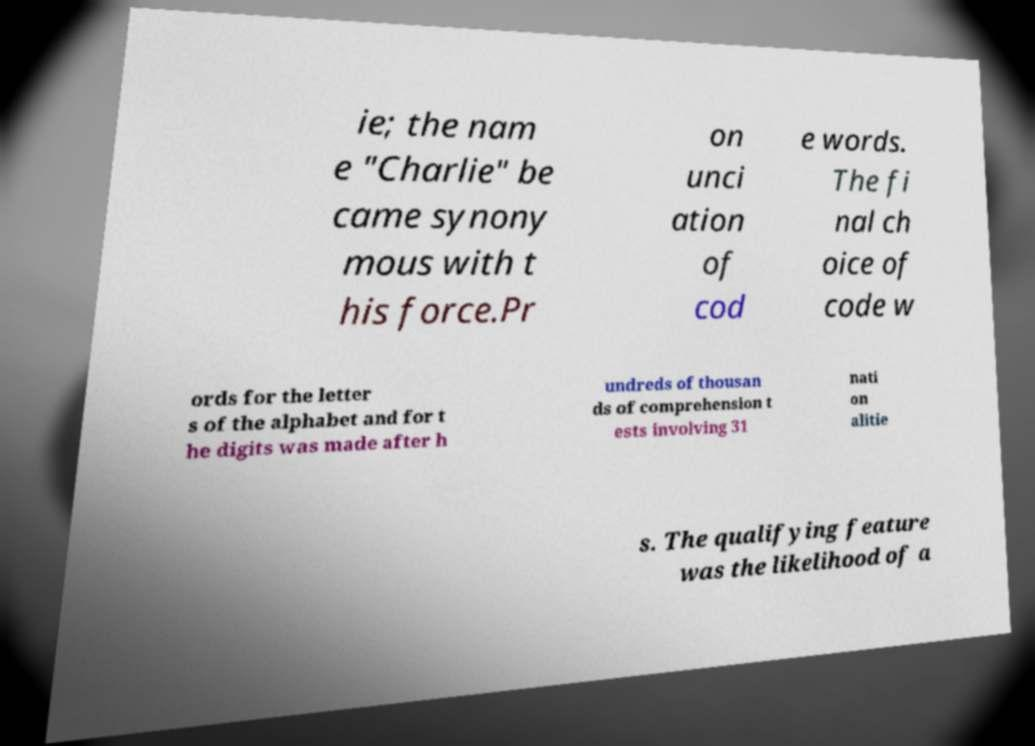For documentation purposes, I need the text within this image transcribed. Could you provide that? ie; the nam e "Charlie" be came synony mous with t his force.Pr on unci ation of cod e words. The fi nal ch oice of code w ords for the letter s of the alphabet and for t he digits was made after h undreds of thousan ds of comprehension t ests involving 31 nati on alitie s. The qualifying feature was the likelihood of a 